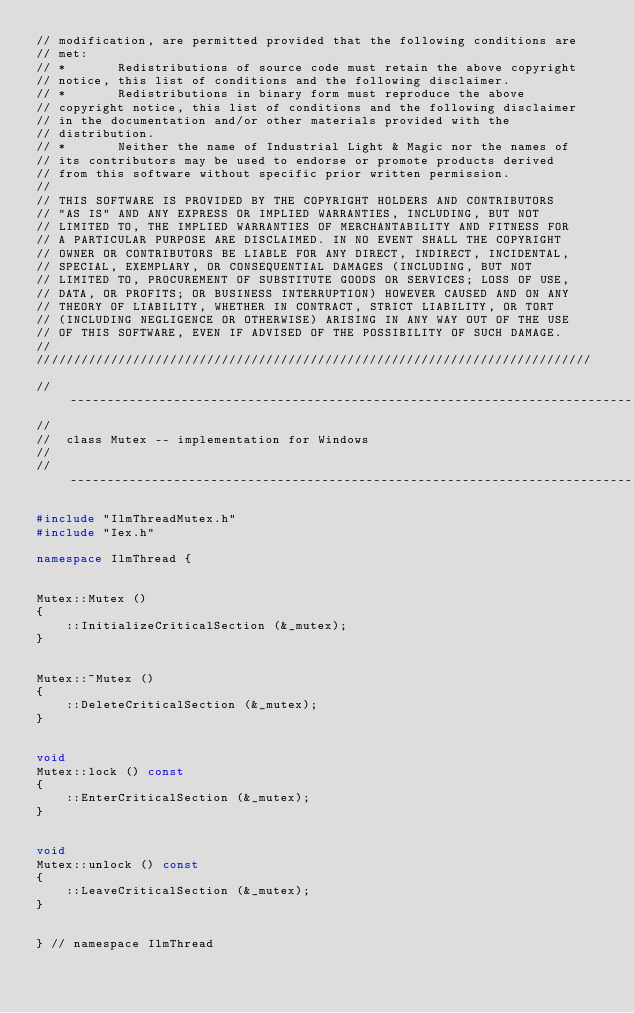Convert code to text. <code><loc_0><loc_0><loc_500><loc_500><_C++_>// modification, are permitted provided that the following conditions are
// met:
// *       Redistributions of source code must retain the above copyright
// notice, this list of conditions and the following disclaimer.
// *       Redistributions in binary form must reproduce the above
// copyright notice, this list of conditions and the following disclaimer
// in the documentation and/or other materials provided with the
// distribution.
// *       Neither the name of Industrial Light & Magic nor the names of
// its contributors may be used to endorse or promote products derived
// from this software without specific prior written permission. 
// 
// THIS SOFTWARE IS PROVIDED BY THE COPYRIGHT HOLDERS AND CONTRIBUTORS
// "AS IS" AND ANY EXPRESS OR IMPLIED WARRANTIES, INCLUDING, BUT NOT
// LIMITED TO, THE IMPLIED WARRANTIES OF MERCHANTABILITY AND FITNESS FOR
// A PARTICULAR PURPOSE ARE DISCLAIMED. IN NO EVENT SHALL THE COPYRIGHT
// OWNER OR CONTRIBUTORS BE LIABLE FOR ANY DIRECT, INDIRECT, INCIDENTAL,
// SPECIAL, EXEMPLARY, OR CONSEQUENTIAL DAMAGES (INCLUDING, BUT NOT
// LIMITED TO, PROCUREMENT OF SUBSTITUTE GOODS OR SERVICES; LOSS OF USE,
// DATA, OR PROFITS; OR BUSINESS INTERRUPTION) HOWEVER CAUSED AND ON ANY
// THEORY OF LIABILITY, WHETHER IN CONTRACT, STRICT LIABILITY, OR TORT
// (INCLUDING NEGLIGENCE OR OTHERWISE) ARISING IN ANY WAY OUT OF THE USE
// OF THIS SOFTWARE, EVEN IF ADVISED OF THE POSSIBILITY OF SUCH DAMAGE.
//
///////////////////////////////////////////////////////////////////////////

//-----------------------------------------------------------------------------
//
//	class Mutex -- implementation for Windows
//
//-----------------------------------------------------------------------------

#include "IlmThreadMutex.h"
#include "Iex.h"

namespace IlmThread {


Mutex::Mutex ()
{
    ::InitializeCriticalSection (&_mutex);
}


Mutex::~Mutex ()
{
    ::DeleteCriticalSection (&_mutex);
}


void
Mutex::lock () const
{
    ::EnterCriticalSection (&_mutex);
}


void
Mutex::unlock () const
{
    ::LeaveCriticalSection (&_mutex);
}


} // namespace IlmThread
</code> 